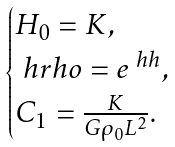<formula> <loc_0><loc_0><loc_500><loc_500>\begin{cases} H _ { 0 } = K , \\ \ h r h o = e ^ { \ h h } , \\ C _ { 1 } = \frac { K } { G \rho _ { 0 } L ^ { 2 } } . \end{cases}</formula> 